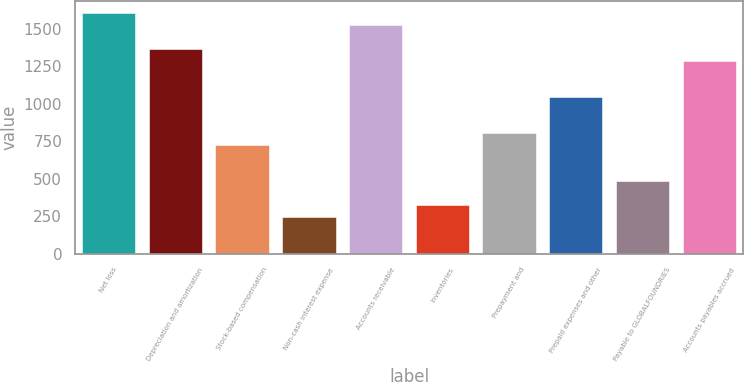Convert chart to OTSL. <chart><loc_0><loc_0><loc_500><loc_500><bar_chart><fcel>Net loss<fcel>Depreciation and amortization<fcel>Stock-based compensation<fcel>Non-cash interest expense<fcel>Accounts receivable<fcel>Inventories<fcel>Prepayment and<fcel>Prepaid expenses and other<fcel>Payable to GLOBALFOUNDRIES<fcel>Accounts payables accrued<nl><fcel>1608<fcel>1367.1<fcel>724.7<fcel>242.9<fcel>1527.7<fcel>323.2<fcel>805<fcel>1045.9<fcel>483.8<fcel>1286.8<nl></chart> 